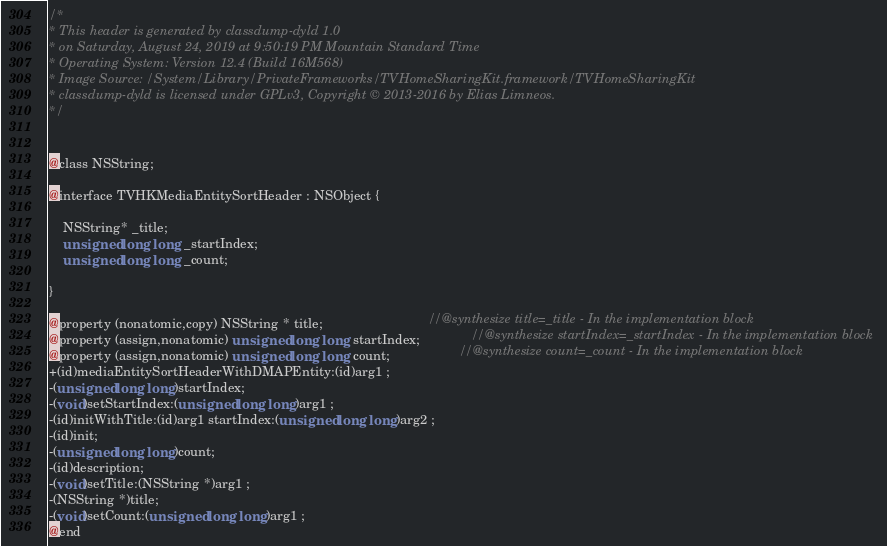Convert code to text. <code><loc_0><loc_0><loc_500><loc_500><_C_>/*
* This header is generated by classdump-dyld 1.0
* on Saturday, August 24, 2019 at 9:50:19 PM Mountain Standard Time
* Operating System: Version 12.4 (Build 16M568)
* Image Source: /System/Library/PrivateFrameworks/TVHomeSharingKit.framework/TVHomeSharingKit
* classdump-dyld is licensed under GPLv3, Copyright © 2013-2016 by Elias Limneos.
*/


@class NSString;

@interface TVHKMediaEntitySortHeader : NSObject {

	NSString* _title;
	unsigned long long _startIndex;
	unsigned long long _count;

}

@property (nonatomic,copy) NSString * title;                             //@synthesize title=_title - In the implementation block
@property (assign,nonatomic) unsigned long long startIndex;              //@synthesize startIndex=_startIndex - In the implementation block
@property (assign,nonatomic) unsigned long long count;                   //@synthesize count=_count - In the implementation block
+(id)mediaEntitySortHeaderWithDMAPEntity:(id)arg1 ;
-(unsigned long long)startIndex;
-(void)setStartIndex:(unsigned long long)arg1 ;
-(id)initWithTitle:(id)arg1 startIndex:(unsigned long long)arg2 ;
-(id)init;
-(unsigned long long)count;
-(id)description;
-(void)setTitle:(NSString *)arg1 ;
-(NSString *)title;
-(void)setCount:(unsigned long long)arg1 ;
@end

</code> 